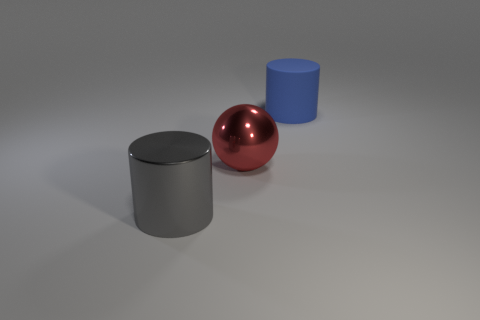Subtract all gray cylinders. How many cylinders are left? 1 Add 1 big blue matte cylinders. How many objects exist? 4 Subtract all cylinders. How many objects are left? 1 Subtract all purple balls. Subtract all gray cylinders. How many balls are left? 1 Subtract all gray spheres. How many cyan cylinders are left? 0 Subtract all tiny green blocks. Subtract all large metallic objects. How many objects are left? 1 Add 3 large metallic objects. How many large metallic objects are left? 5 Add 1 blue shiny spheres. How many blue shiny spheres exist? 1 Subtract 0 purple cylinders. How many objects are left? 3 Subtract 1 cylinders. How many cylinders are left? 1 